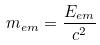Convert formula to latex. <formula><loc_0><loc_0><loc_500><loc_500>m _ { e m } = \frac { E _ { e m } } { c ^ { 2 } }</formula> 